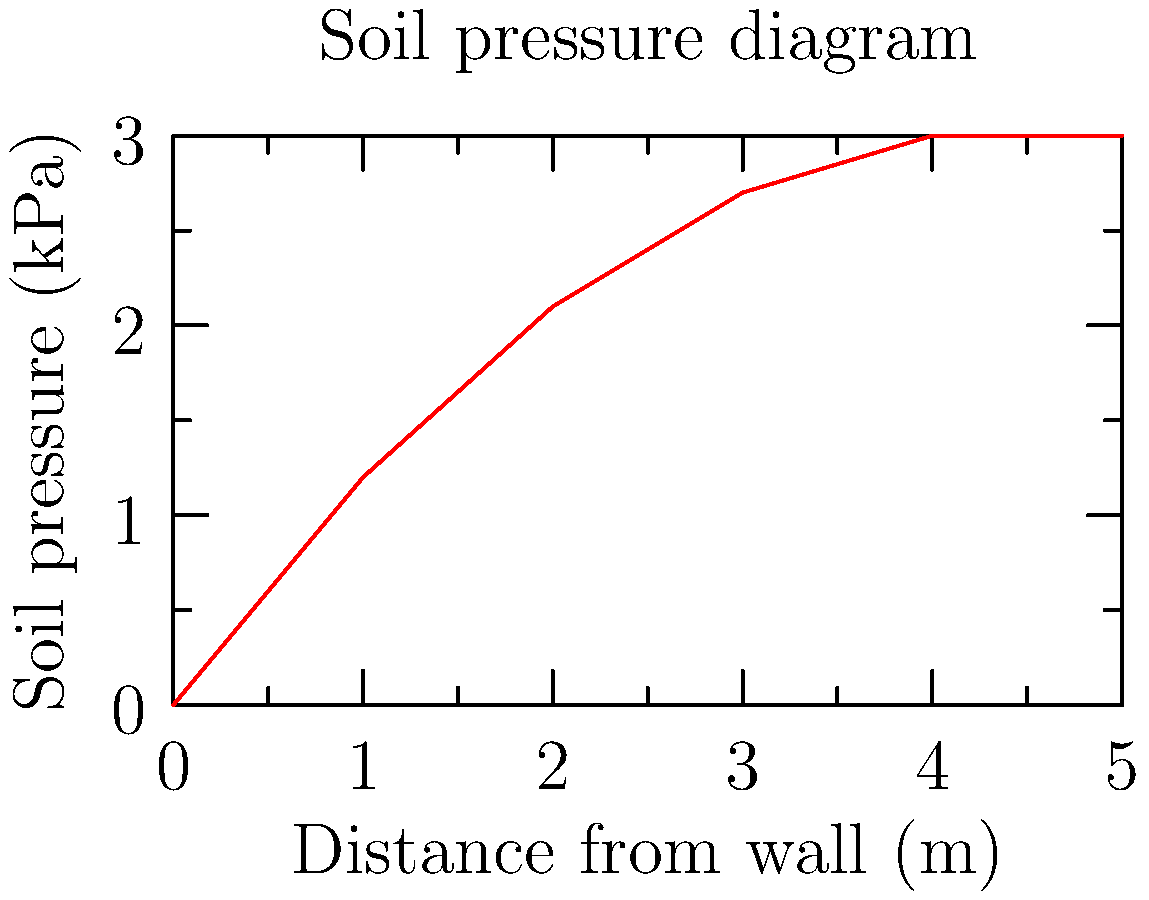As a pitcher constantly working on mechanics, you understand the importance of optimal angles. In civil engineering, determining the optimal angle for a retaining wall is crucial. Given the soil pressure diagram above, what is the optimal angle $\theta$ (in degrees) for the retaining wall to minimize the overturning moment? To determine the optimal angle for the retaining wall, we'll follow these steps:

1. Analyze the soil pressure diagram:
   The diagram shows pressure increasing non-linearly with depth, typical for cohesive soils.

2. Determine the resultant force:
   The resultant force is represented by the area under the pressure curve.
   Area ≈ $\frac{1}{2} \times 5m \times 3kPa = 7.5 kN/m$

3. Find the line of action:
   The centroid of the pressure diagram is approximately at 1/3 of the wall height from the base.
   Line of action ≈ $5m \times \frac{1}{3} = 1.67m$ from the base

4. Calculate the optimal angle:
   The optimal angle minimizes the overturning moment by directing the resultant force through the base of the wall.
   $\tan(\theta) = \frac{opposite}{adjacent} = \frac{1.67m}{5m}$
   $\theta = \arctan(\frac{1.67}{5}) \approx 18.43°$

5. Round to the nearest degree:
   $\theta ≈ 18°$

This angle ensures that the resultant force passes through the base of the wall, minimizing the overturning moment and optimizing stability.
Answer: 18° 